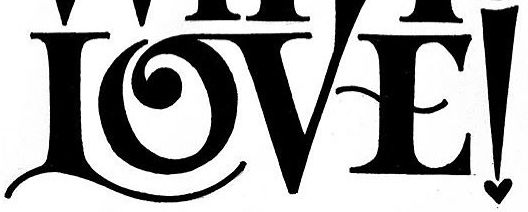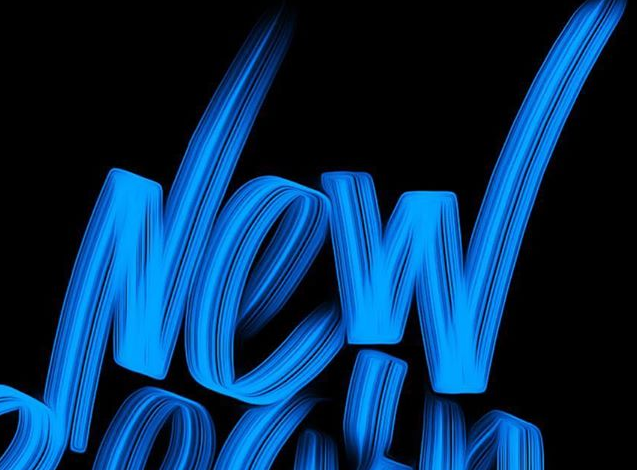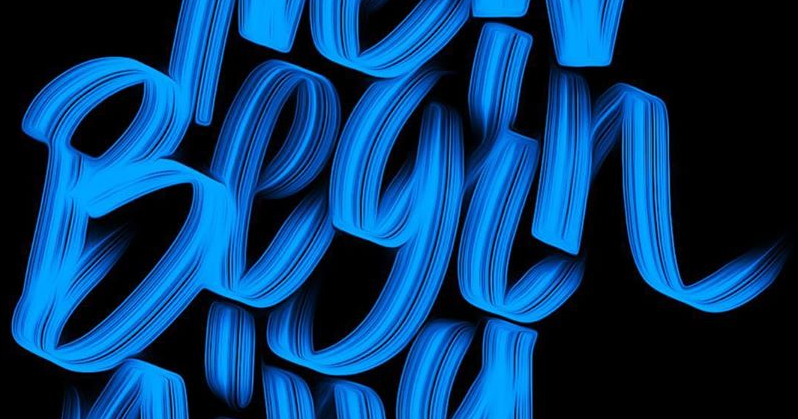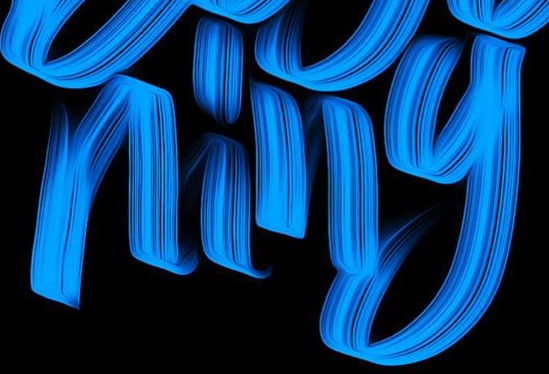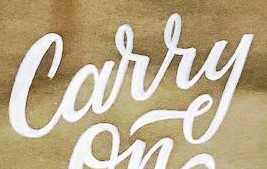What text appears in these images from left to right, separated by a semicolon? LOVE!; New; Begin; ning; Carry 